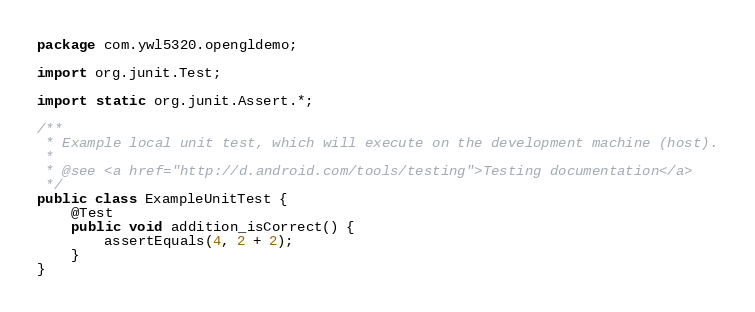<code> <loc_0><loc_0><loc_500><loc_500><_Java_>package com.ywl5320.opengldemo;

import org.junit.Test;

import static org.junit.Assert.*;

/**
 * Example local unit test, which will execute on the development machine (host).
 *
 * @see <a href="http://d.android.com/tools/testing">Testing documentation</a>
 */
public class ExampleUnitTest {
    @Test
    public void addition_isCorrect() {
        assertEquals(4, 2 + 2);
    }
}</code> 